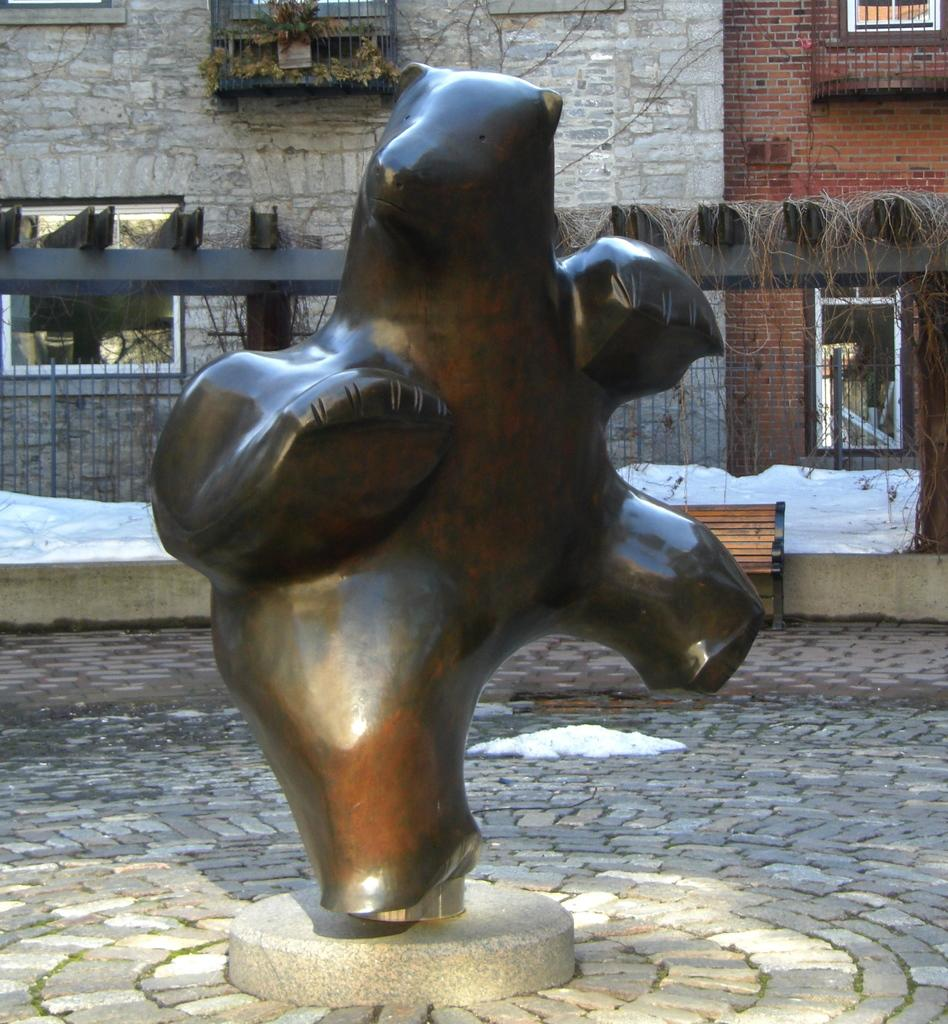What is the main subject in the middle of the image? There is a statue in the middle of the image. What can be seen in the background of the image? There are buildings visible in the background of the image. How many pigs are sitting on the statue in the image? There are no pigs present in the image; it features a statue and buildings in the background. What type of drug can be seen in the hands of the statue in the image? There is no drug present in the image; it features a statue and buildings in the background. 